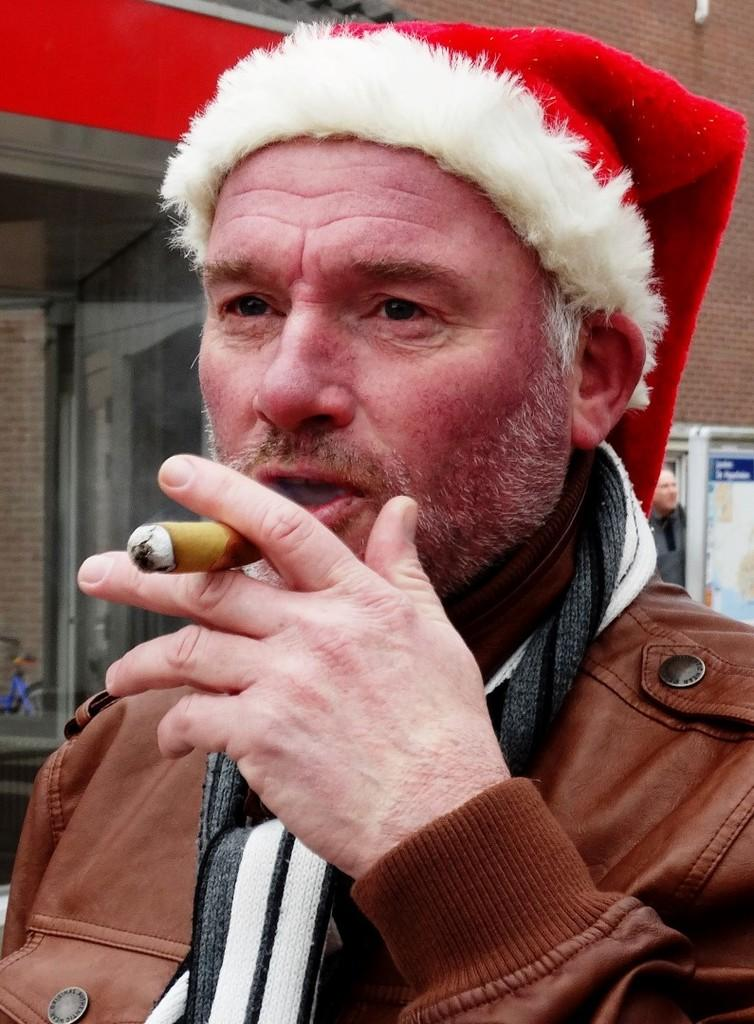What is the person in the image doing? The person in the image is smoking. What can be seen in the background of the image? There is a building behind the person smoking. Are there any other people visible in the image? Yes, there is another person standing in front of the building. What type of hose is being used by the person smoking in the image? There is no hose present in the image; the person is smoking a cigarette or a similar object. What season is it in the image, given the presence of summer clothing? The provided facts do not mention any clothing or seasonal details, so it cannot be determined if it is summer or any other season. 